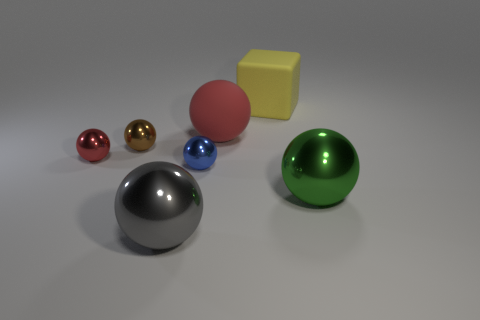There is a red ball that is to the right of the tiny red metallic object that is to the left of the large metal sphere that is on the left side of the large yellow rubber thing; what is its size?
Keep it short and to the point. Large. There is a red ball on the right side of the brown object; what size is it?
Offer a very short reply. Large. What number of gray things are either shiny spheres or small shiny spheres?
Offer a very short reply. 1. Is there a red matte thing that has the same size as the yellow thing?
Provide a succinct answer. Yes. There is a red ball that is the same size as the yellow object; what is it made of?
Offer a terse response. Rubber. Do the object that is in front of the green ball and the brown shiny object in front of the matte ball have the same size?
Offer a very short reply. No. What number of things are either big yellow rubber cubes or spheres behind the blue metallic sphere?
Provide a succinct answer. 4. Are there any small red things of the same shape as the gray metallic object?
Offer a very short reply. Yes. How big is the red sphere that is in front of the red ball on the right side of the blue object?
Give a very brief answer. Small. Does the large block have the same color as the big rubber ball?
Offer a very short reply. No. 